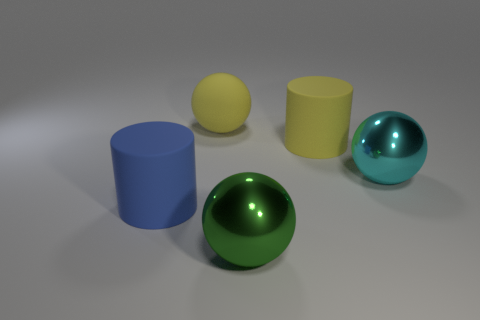What material is the green object left of the yellow matte cylinder?
Ensure brevity in your answer.  Metal. What number of matte things are either tiny red spheres or large green spheres?
Make the answer very short. 0. There is a large cylinder that is in front of the large yellow thing that is in front of the big yellow rubber ball; what is its color?
Offer a very short reply. Blue. Is the material of the green object the same as the large cyan object that is to the right of the matte sphere?
Ensure brevity in your answer.  Yes. There is a big object to the right of the cylinder that is to the right of the rubber sphere to the left of the cyan metal thing; what color is it?
Provide a short and direct response. Cyan. Is there any other thing that is the same shape as the big cyan object?
Your answer should be very brief. Yes. Is the number of large blue rubber objects greater than the number of brown cylinders?
Make the answer very short. Yes. How many big rubber objects are behind the large cyan metallic object and in front of the cyan thing?
Make the answer very short. 0. What number of green balls are in front of the large yellow ball that is behind the yellow rubber cylinder?
Provide a short and direct response. 1. Does the rubber cylinder in front of the big cyan object have the same size as the shiny ball behind the large blue matte object?
Make the answer very short. Yes. 